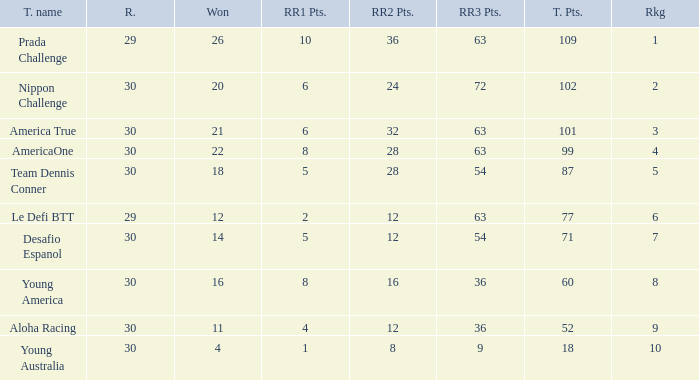Name the total number of rr2 pts for won being 11 1.0. 